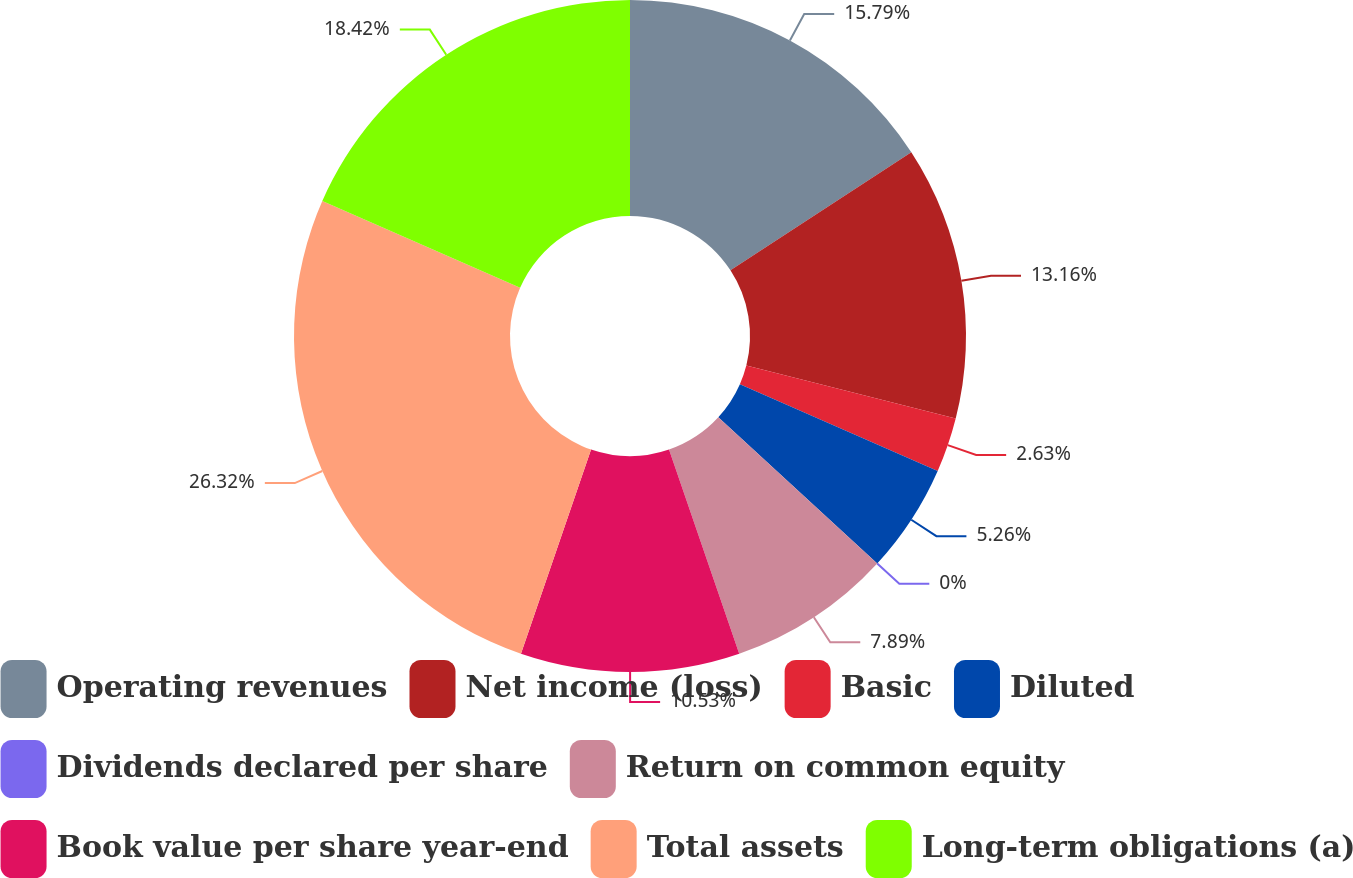Convert chart to OTSL. <chart><loc_0><loc_0><loc_500><loc_500><pie_chart><fcel>Operating revenues<fcel>Net income (loss)<fcel>Basic<fcel>Diluted<fcel>Dividends declared per share<fcel>Return on common equity<fcel>Book value per share year-end<fcel>Total assets<fcel>Long-term obligations (a)<nl><fcel>15.79%<fcel>13.16%<fcel>2.63%<fcel>5.26%<fcel>0.0%<fcel>7.89%<fcel>10.53%<fcel>26.32%<fcel>18.42%<nl></chart> 